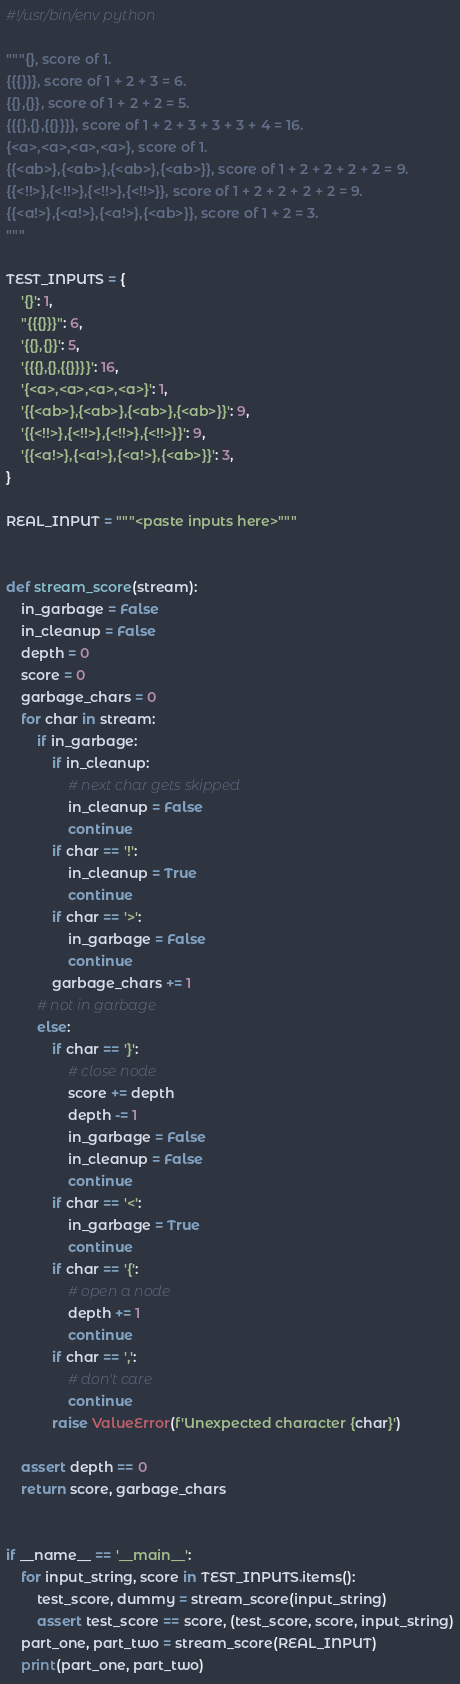Convert code to text. <code><loc_0><loc_0><loc_500><loc_500><_Python_>#!/usr/bin/env python

"""{}, score of 1.
{{{}}}, score of 1 + 2 + 3 = 6.
{{},{}}, score of 1 + 2 + 2 = 5.
{{{},{},{{}}}}, score of 1 + 2 + 3 + 3 + 3 + 4 = 16.
{<a>,<a>,<a>,<a>}, score of 1.
{{<ab>},{<ab>},{<ab>},{<ab>}}, score of 1 + 2 + 2 + 2 + 2 = 9.
{{<!!>},{<!!>},{<!!>},{<!!>}}, score of 1 + 2 + 2 + 2 + 2 = 9.
{{<a!>},{<a!>},{<a!>},{<ab>}}, score of 1 + 2 = 3.
"""

TEST_INPUTS = {
    '{}': 1,
    "{{{}}}": 6,
    '{{},{}}': 5,
    '{{{},{},{{}}}}': 16,
    '{<a>,<a>,<a>,<a>}': 1,
    '{{<ab>},{<ab>},{<ab>},{<ab>}}': 9,
    '{{<!!>},{<!!>},{<!!>},{<!!>}}': 9,
    '{{<a!>},{<a!>},{<a!>},{<ab>}}': 3,
}

REAL_INPUT = """<paste inputs here>"""


def stream_score(stream):
    in_garbage = False
    in_cleanup = False
    depth = 0
    score = 0
    garbage_chars = 0
    for char in stream:
        if in_garbage:
            if in_cleanup:
                # next char gets skipped
                in_cleanup = False
                continue
            if char == '!':
                in_cleanup = True
                continue
            if char == '>':
                in_garbage = False
                continue
            garbage_chars += 1
        # not in garbage
        else:
            if char == '}':
                # close node
                score += depth
                depth -= 1
                in_garbage = False
                in_cleanup = False
                continue
            if char == '<':
                in_garbage = True
                continue
            if char == '{':
                # open a node
                depth += 1
                continue
            if char == ',':
                # don't care
                continue
            raise ValueError(f'Unexpected character {char}')

    assert depth == 0
    return score, garbage_chars


if __name__ == '__main__':
    for input_string, score in TEST_INPUTS.items():
        test_score, dummy = stream_score(input_string)
        assert test_score == score, (test_score, score, input_string)
    part_one, part_two = stream_score(REAL_INPUT)
    print(part_one, part_two)
</code> 